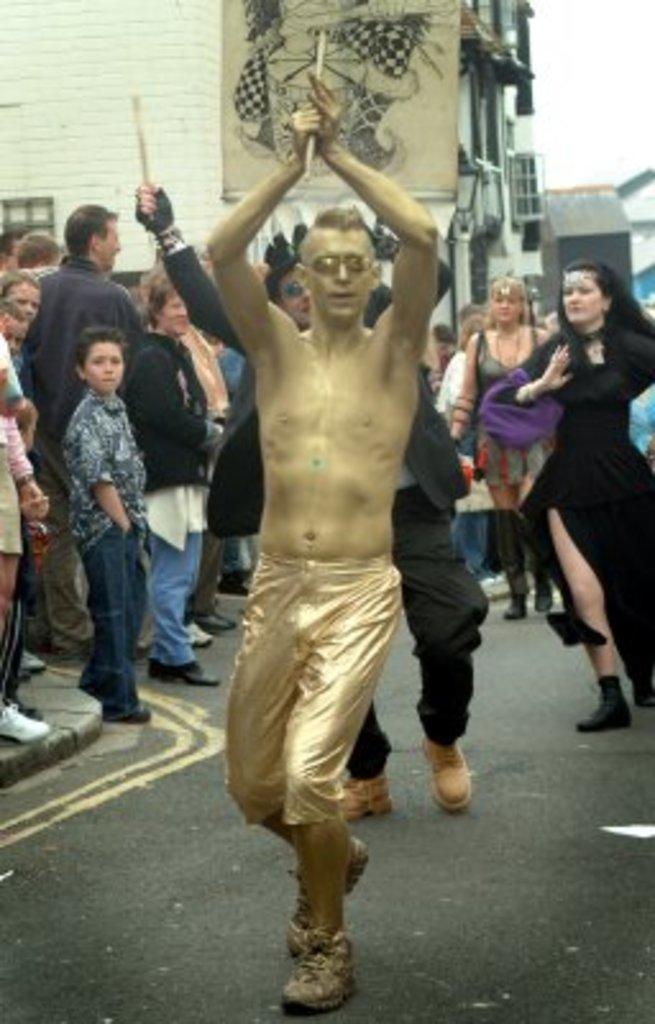In one or two sentences, can you explain what this image depicts? In this image, we can see a group of people. Few people are holding some objects and doing perform on the road. Background we can see buildings, walls, banner and few objects. 